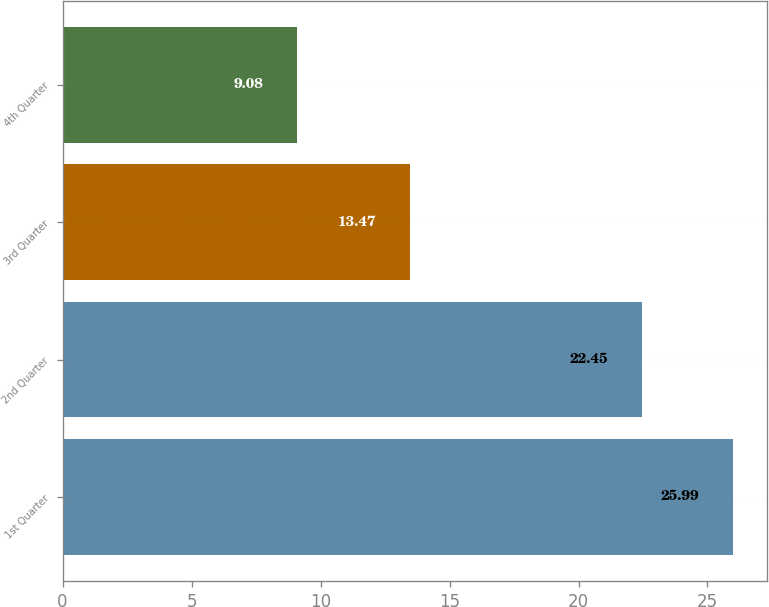<chart> <loc_0><loc_0><loc_500><loc_500><bar_chart><fcel>1st Quarter<fcel>2nd Quarter<fcel>3rd Quarter<fcel>4th Quarter<nl><fcel>25.99<fcel>22.45<fcel>13.47<fcel>9.08<nl></chart> 